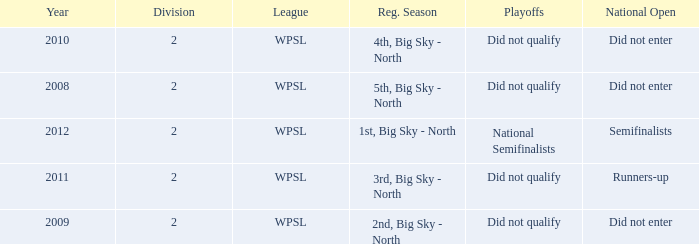What is the highest number of divisions mentioned? 2.0. 